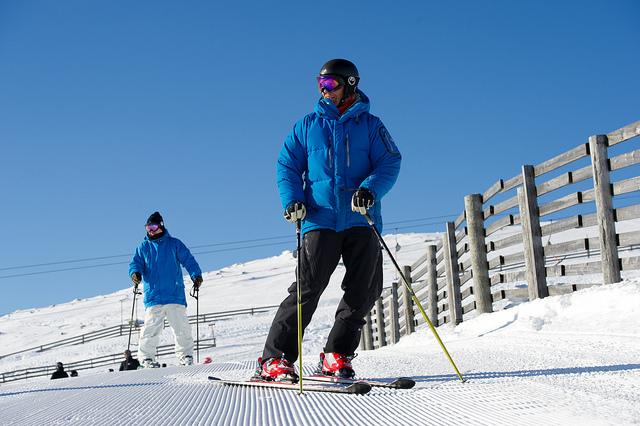Has the snow been plowed/smoothed over?
Quick response, please. Yes. Are then men looking to the right?
Keep it brief. Yes. What is the color of the jackets they are wearing?
Write a very short answer. Blue. 